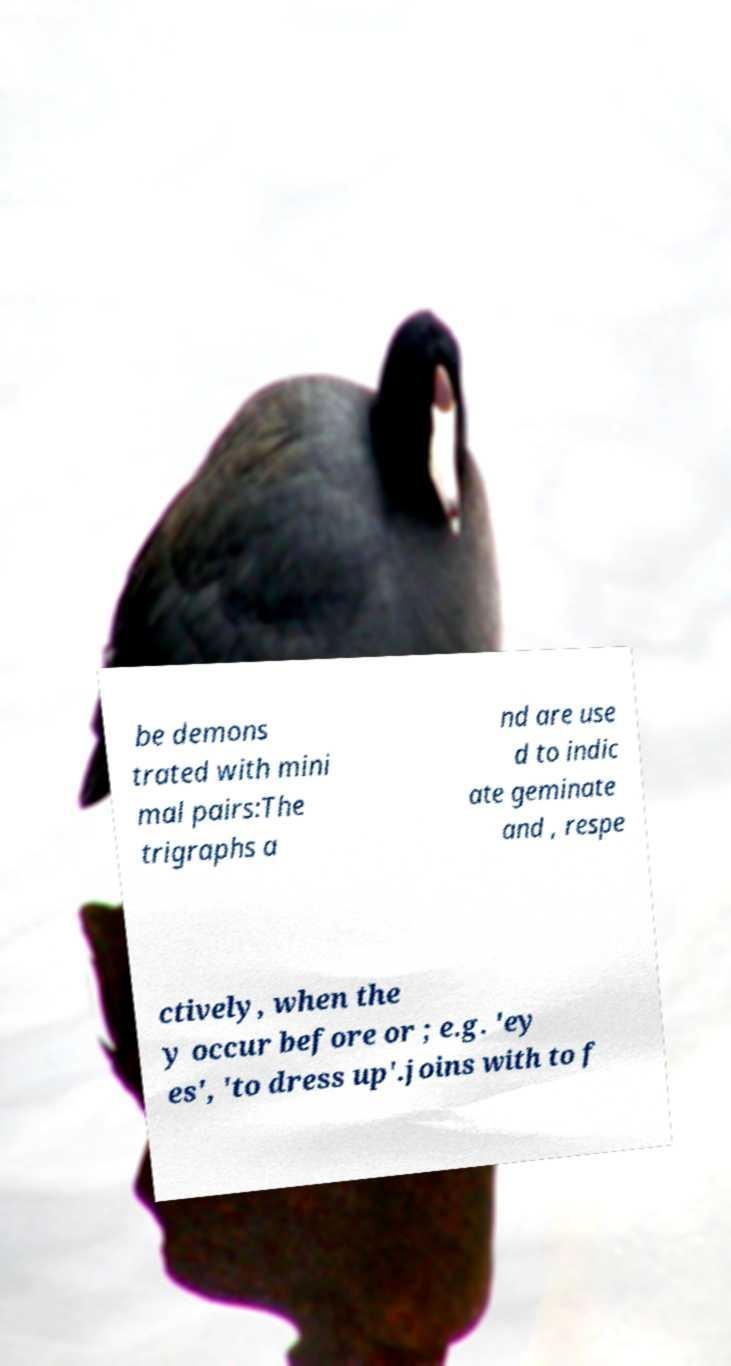Please identify and transcribe the text found in this image. be demons trated with mini mal pairs:The trigraphs a nd are use d to indic ate geminate and , respe ctively, when the y occur before or ; e.g. 'ey es', 'to dress up'.joins with to f 